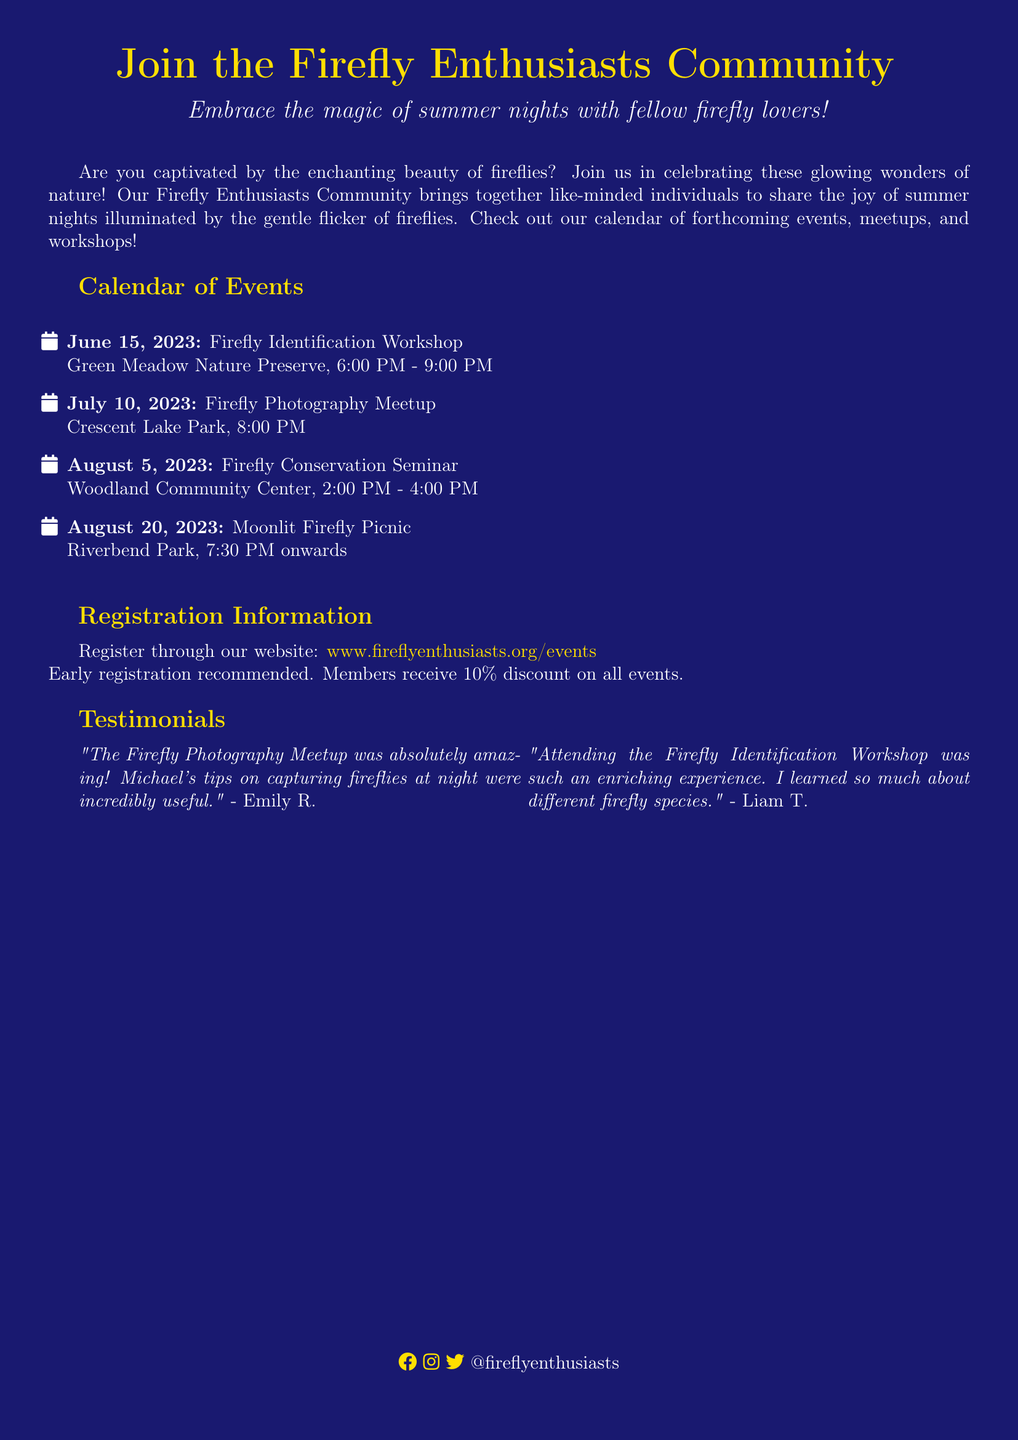What is the date of the Firefly Identification Workshop? This event is listed in the calendar with the specific date provided.
Answer: June 15, 2023 Where is the Firefly Photography Meetup taking place? The location for this event is mentioned in the details of the Meetup.
Answer: Crescent Lake Park What time does the Moonlit Firefly Picnic start? The start time for this picnic is specified in the event details.
Answer: 7:30 PM What percentage discount do members receive for events? This information is given in the registration section of the flyer.
Answer: 10% Which event focuses on firefly conservation? This is identified by looking at the titles of the upcoming events.
Answer: Firefly Conservation Seminar Who is quoted in the testimonial about the Firefly Photography Meetup? The individual's name is mentioned directly in the testimonial provided in the document.
Answer: Emily R How long does the Firefly Conservation Seminar last? This information is found in the duration details of the seminar listed.
Answer: 2 hours What is the theme of the events organized by the community? This can be derived from the overall purpose of the community as stated in the opening statements.
Answer: Fireflies 